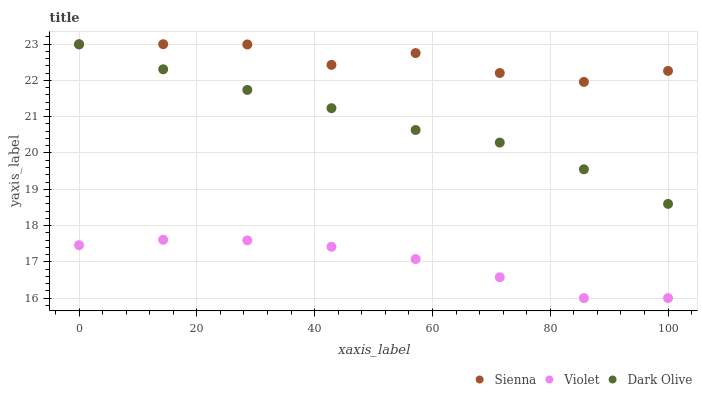Does Violet have the minimum area under the curve?
Answer yes or no. Yes. Does Sienna have the maximum area under the curve?
Answer yes or no. Yes. Does Dark Olive have the minimum area under the curve?
Answer yes or no. No. Does Dark Olive have the maximum area under the curve?
Answer yes or no. No. Is Dark Olive the smoothest?
Answer yes or no. Yes. Is Sienna the roughest?
Answer yes or no. Yes. Is Violet the smoothest?
Answer yes or no. No. Is Violet the roughest?
Answer yes or no. No. Does Violet have the lowest value?
Answer yes or no. Yes. Does Dark Olive have the lowest value?
Answer yes or no. No. Does Sienna have the highest value?
Answer yes or no. Yes. Does Dark Olive have the highest value?
Answer yes or no. No. Is Violet less than Sienna?
Answer yes or no. Yes. Is Sienna greater than Dark Olive?
Answer yes or no. Yes. Does Violet intersect Sienna?
Answer yes or no. No. 